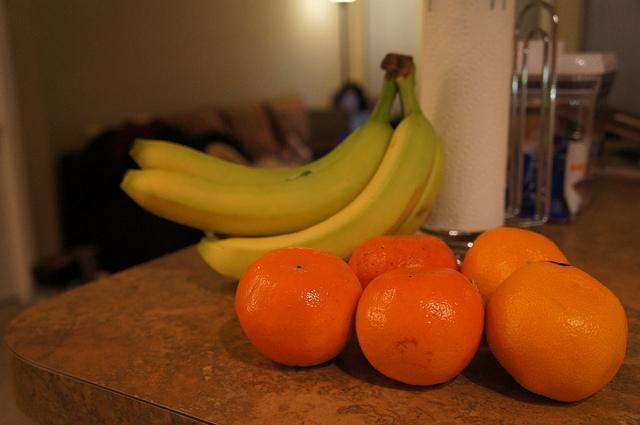How many pineapples are there?
Give a very brief answer. 0. How many oranges are in the picture?
Give a very brief answer. 5. 